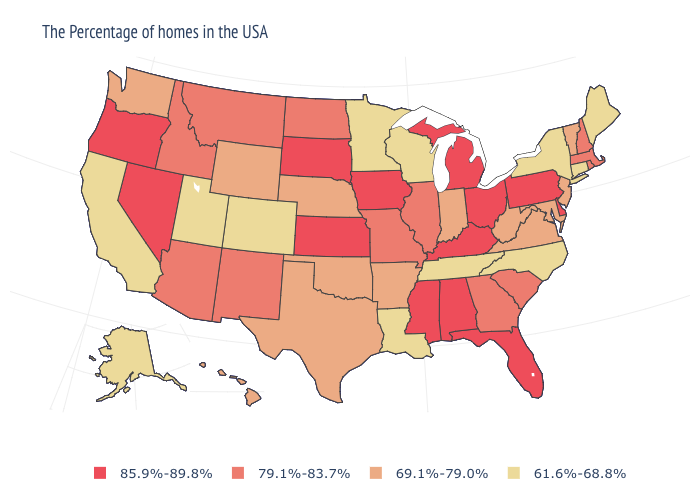Name the states that have a value in the range 79.1%-83.7%?
Give a very brief answer. Massachusetts, Rhode Island, New Hampshire, South Carolina, Georgia, Illinois, Missouri, North Dakota, New Mexico, Montana, Arizona, Idaho. What is the value of Wyoming?
Be succinct. 69.1%-79.0%. Name the states that have a value in the range 79.1%-83.7%?
Give a very brief answer. Massachusetts, Rhode Island, New Hampshire, South Carolina, Georgia, Illinois, Missouri, North Dakota, New Mexico, Montana, Arizona, Idaho. Name the states that have a value in the range 69.1%-79.0%?
Concise answer only. Vermont, New Jersey, Maryland, Virginia, West Virginia, Indiana, Arkansas, Nebraska, Oklahoma, Texas, Wyoming, Washington, Hawaii. Does Missouri have a lower value than South Carolina?
Answer briefly. No. What is the lowest value in the USA?
Short answer required. 61.6%-68.8%. Is the legend a continuous bar?
Concise answer only. No. Name the states that have a value in the range 79.1%-83.7%?
Keep it brief. Massachusetts, Rhode Island, New Hampshire, South Carolina, Georgia, Illinois, Missouri, North Dakota, New Mexico, Montana, Arizona, Idaho. Does Nebraska have the lowest value in the MidWest?
Keep it brief. No. What is the highest value in the USA?
Concise answer only. 85.9%-89.8%. What is the highest value in states that border Tennessee?
Answer briefly. 85.9%-89.8%. Does Alabama have a higher value than Utah?
Short answer required. Yes. What is the value of Florida?
Be succinct. 85.9%-89.8%. Does the first symbol in the legend represent the smallest category?
Answer briefly. No. Which states have the lowest value in the MidWest?
Concise answer only. Wisconsin, Minnesota. 